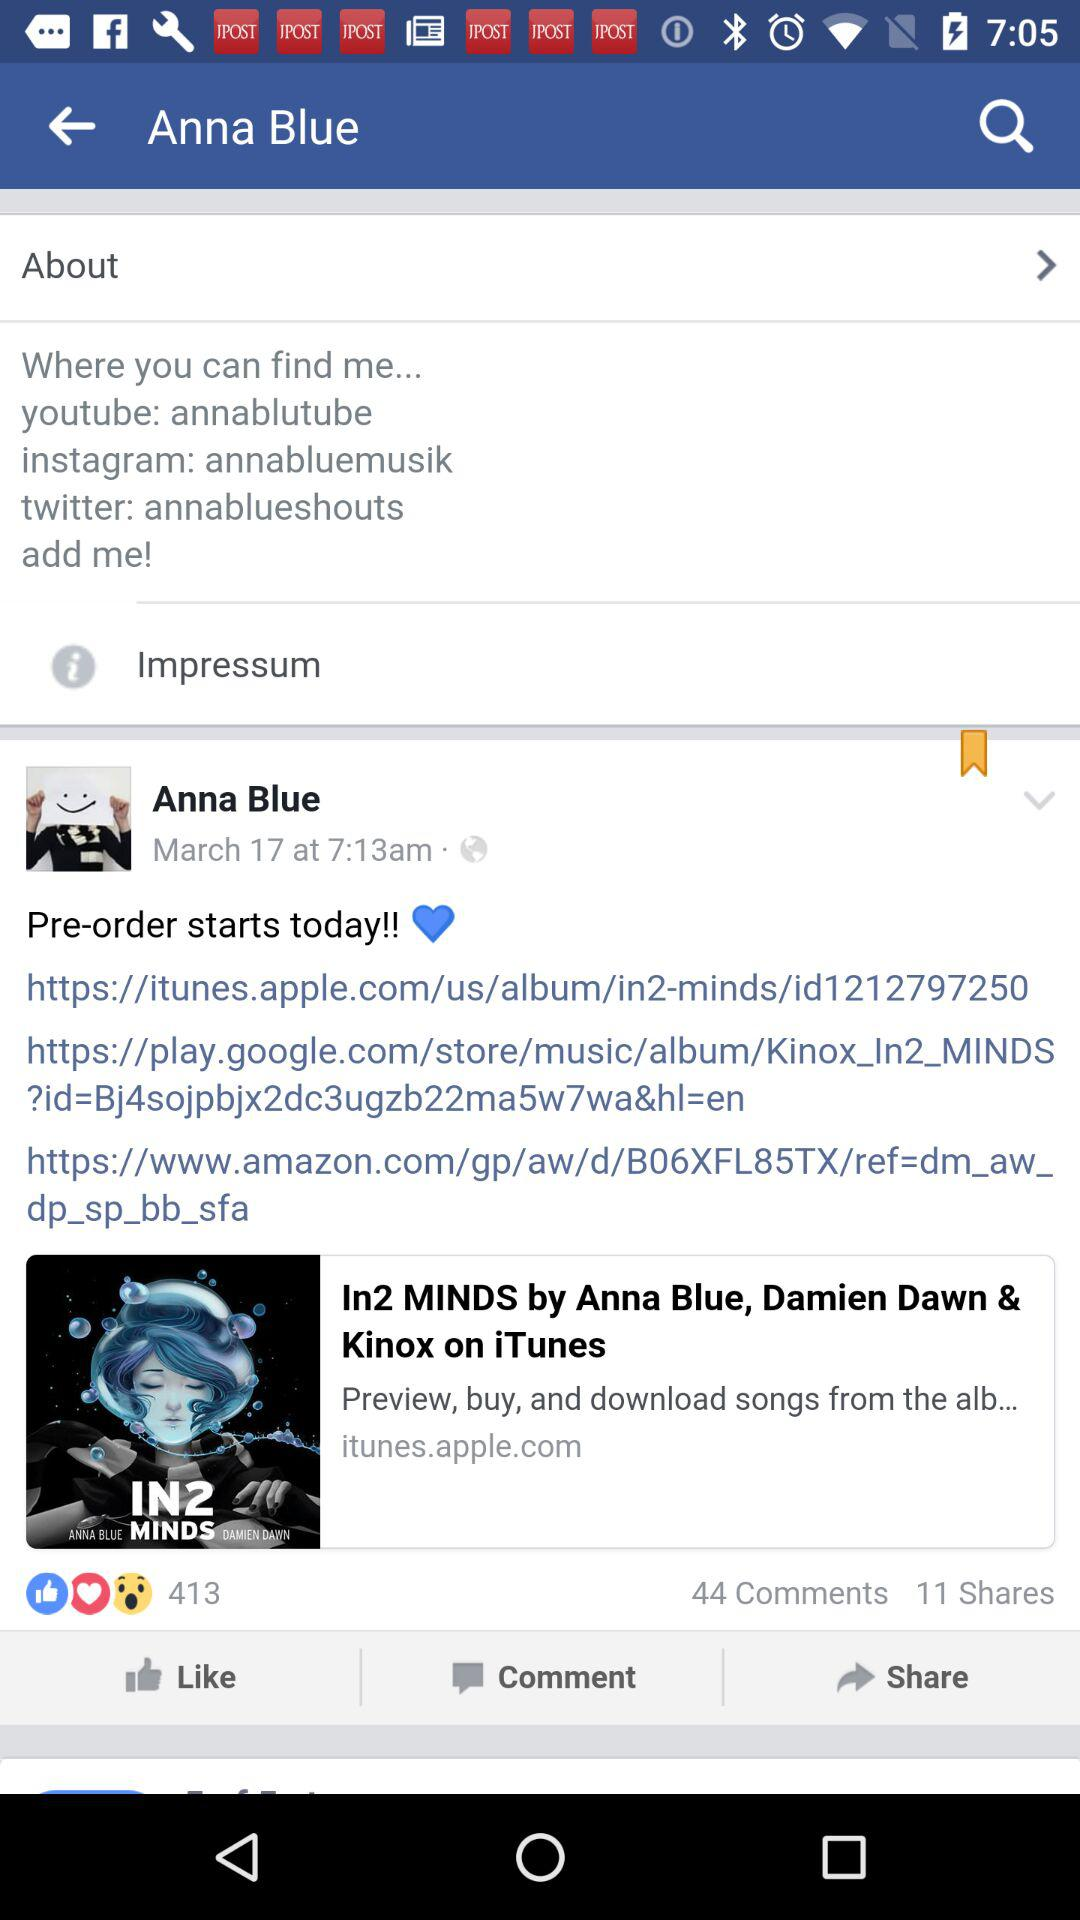What is the number of shares? The number of shares is 11. 